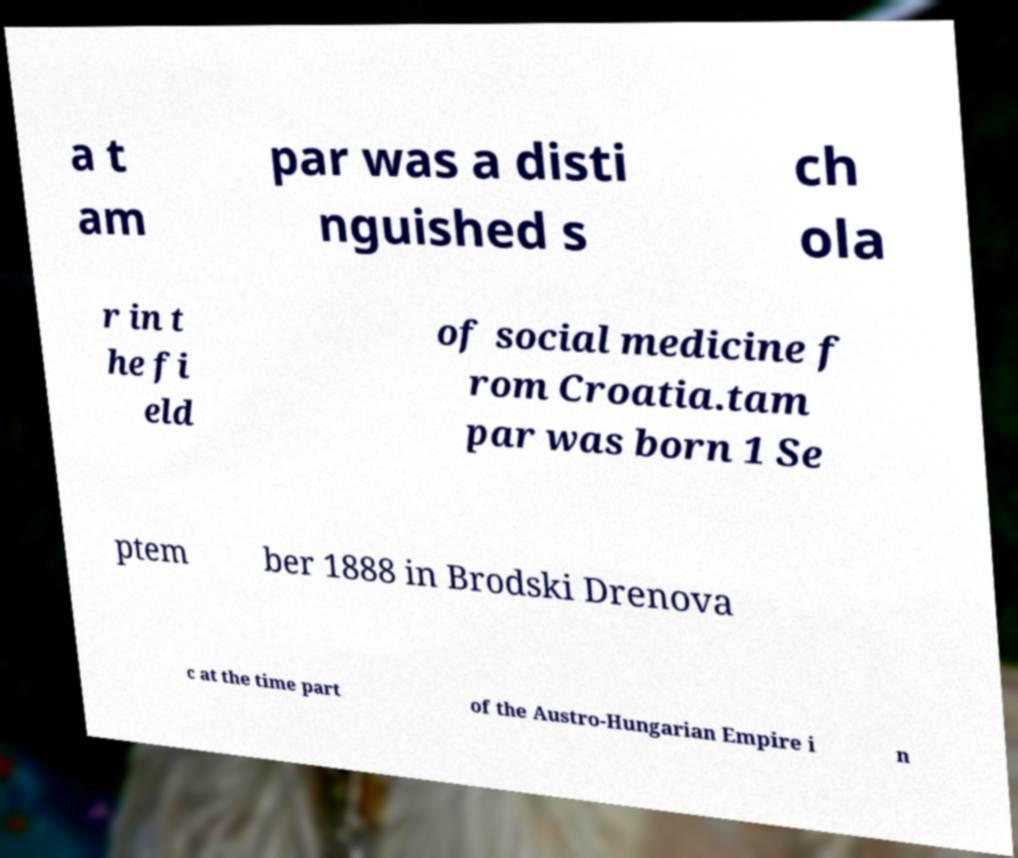For documentation purposes, I need the text within this image transcribed. Could you provide that? a t am par was a disti nguished s ch ola r in t he fi eld of social medicine f rom Croatia.tam par was born 1 Se ptem ber 1888 in Brodski Drenova c at the time part of the Austro-Hungarian Empire i n 